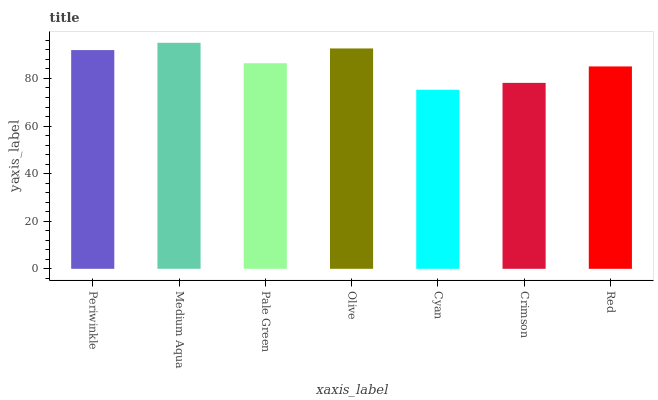Is Pale Green the minimum?
Answer yes or no. No. Is Pale Green the maximum?
Answer yes or no. No. Is Medium Aqua greater than Pale Green?
Answer yes or no. Yes. Is Pale Green less than Medium Aqua?
Answer yes or no. Yes. Is Pale Green greater than Medium Aqua?
Answer yes or no. No. Is Medium Aqua less than Pale Green?
Answer yes or no. No. Is Pale Green the high median?
Answer yes or no. Yes. Is Pale Green the low median?
Answer yes or no. Yes. Is Periwinkle the high median?
Answer yes or no. No. Is Crimson the low median?
Answer yes or no. No. 